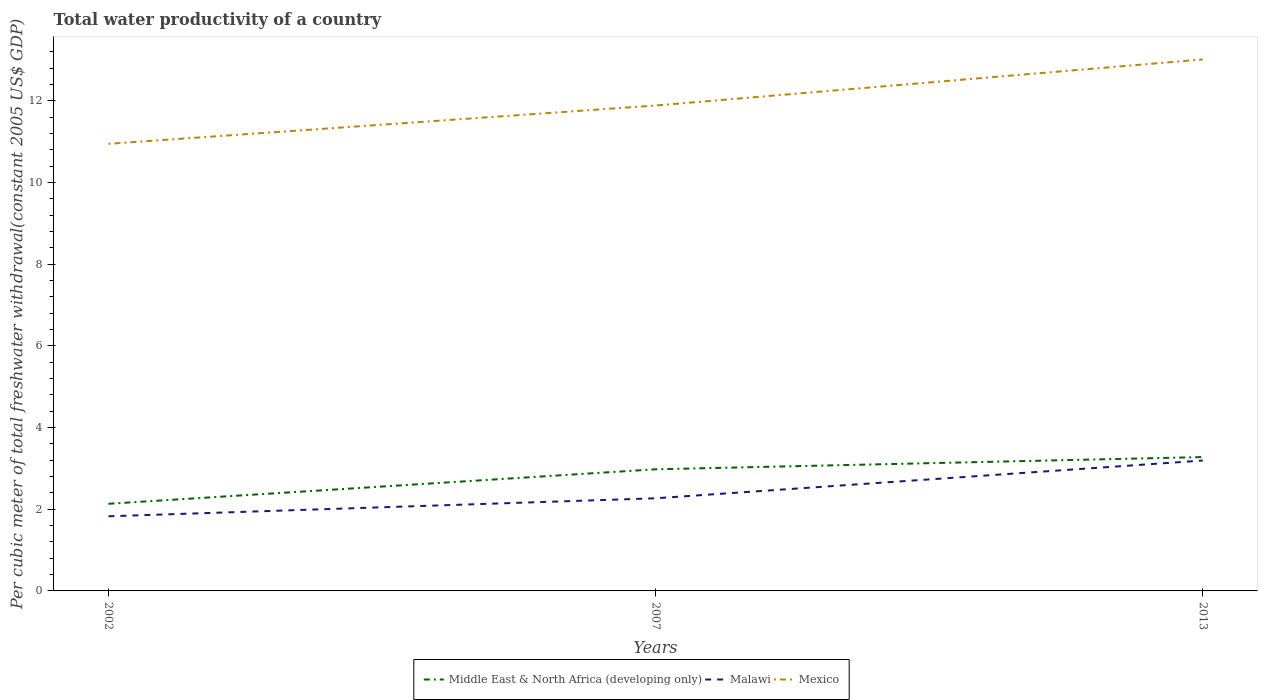Across all years, what is the maximum total water productivity in Mexico?
Keep it short and to the point. 10.95. In which year was the total water productivity in Malawi maximum?
Offer a terse response. 2002. What is the total total water productivity in Malawi in the graph?
Make the answer very short. -0.44. What is the difference between the highest and the second highest total water productivity in Middle East & North Africa (developing only)?
Provide a short and direct response. 1.14. What is the difference between the highest and the lowest total water productivity in Malawi?
Give a very brief answer. 1. Is the total water productivity in Mexico strictly greater than the total water productivity in Middle East & North Africa (developing only) over the years?
Provide a short and direct response. No. How many lines are there?
Keep it short and to the point. 3. Does the graph contain any zero values?
Offer a very short reply. No. Where does the legend appear in the graph?
Give a very brief answer. Bottom center. How many legend labels are there?
Keep it short and to the point. 3. How are the legend labels stacked?
Your answer should be compact. Horizontal. What is the title of the graph?
Keep it short and to the point. Total water productivity of a country. Does "Middle East & North Africa (all income levels)" appear as one of the legend labels in the graph?
Provide a short and direct response. No. What is the label or title of the X-axis?
Your answer should be compact. Years. What is the label or title of the Y-axis?
Give a very brief answer. Per cubic meter of total freshwater withdrawal(constant 2005 US$ GDP). What is the Per cubic meter of total freshwater withdrawal(constant 2005 US$ GDP) in Middle East & North Africa (developing only) in 2002?
Your answer should be compact. 2.13. What is the Per cubic meter of total freshwater withdrawal(constant 2005 US$ GDP) of Malawi in 2002?
Ensure brevity in your answer.  1.83. What is the Per cubic meter of total freshwater withdrawal(constant 2005 US$ GDP) in Mexico in 2002?
Your answer should be very brief. 10.95. What is the Per cubic meter of total freshwater withdrawal(constant 2005 US$ GDP) in Middle East & North Africa (developing only) in 2007?
Offer a terse response. 2.98. What is the Per cubic meter of total freshwater withdrawal(constant 2005 US$ GDP) in Malawi in 2007?
Give a very brief answer. 2.27. What is the Per cubic meter of total freshwater withdrawal(constant 2005 US$ GDP) in Mexico in 2007?
Your answer should be very brief. 11.89. What is the Per cubic meter of total freshwater withdrawal(constant 2005 US$ GDP) of Middle East & North Africa (developing only) in 2013?
Your response must be concise. 3.28. What is the Per cubic meter of total freshwater withdrawal(constant 2005 US$ GDP) in Malawi in 2013?
Ensure brevity in your answer.  3.19. What is the Per cubic meter of total freshwater withdrawal(constant 2005 US$ GDP) of Mexico in 2013?
Provide a short and direct response. 13.02. Across all years, what is the maximum Per cubic meter of total freshwater withdrawal(constant 2005 US$ GDP) of Middle East & North Africa (developing only)?
Offer a terse response. 3.28. Across all years, what is the maximum Per cubic meter of total freshwater withdrawal(constant 2005 US$ GDP) in Malawi?
Ensure brevity in your answer.  3.19. Across all years, what is the maximum Per cubic meter of total freshwater withdrawal(constant 2005 US$ GDP) in Mexico?
Keep it short and to the point. 13.02. Across all years, what is the minimum Per cubic meter of total freshwater withdrawal(constant 2005 US$ GDP) of Middle East & North Africa (developing only)?
Make the answer very short. 2.13. Across all years, what is the minimum Per cubic meter of total freshwater withdrawal(constant 2005 US$ GDP) in Malawi?
Make the answer very short. 1.83. Across all years, what is the minimum Per cubic meter of total freshwater withdrawal(constant 2005 US$ GDP) in Mexico?
Your answer should be compact. 10.95. What is the total Per cubic meter of total freshwater withdrawal(constant 2005 US$ GDP) in Middle East & North Africa (developing only) in the graph?
Your answer should be compact. 8.39. What is the total Per cubic meter of total freshwater withdrawal(constant 2005 US$ GDP) in Malawi in the graph?
Your answer should be compact. 7.29. What is the total Per cubic meter of total freshwater withdrawal(constant 2005 US$ GDP) in Mexico in the graph?
Ensure brevity in your answer.  35.85. What is the difference between the Per cubic meter of total freshwater withdrawal(constant 2005 US$ GDP) in Middle East & North Africa (developing only) in 2002 and that in 2007?
Give a very brief answer. -0.84. What is the difference between the Per cubic meter of total freshwater withdrawal(constant 2005 US$ GDP) of Malawi in 2002 and that in 2007?
Make the answer very short. -0.44. What is the difference between the Per cubic meter of total freshwater withdrawal(constant 2005 US$ GDP) of Mexico in 2002 and that in 2007?
Your answer should be compact. -0.94. What is the difference between the Per cubic meter of total freshwater withdrawal(constant 2005 US$ GDP) in Middle East & North Africa (developing only) in 2002 and that in 2013?
Make the answer very short. -1.14. What is the difference between the Per cubic meter of total freshwater withdrawal(constant 2005 US$ GDP) in Malawi in 2002 and that in 2013?
Keep it short and to the point. -1.37. What is the difference between the Per cubic meter of total freshwater withdrawal(constant 2005 US$ GDP) of Mexico in 2002 and that in 2013?
Your response must be concise. -2.07. What is the difference between the Per cubic meter of total freshwater withdrawal(constant 2005 US$ GDP) in Middle East & North Africa (developing only) in 2007 and that in 2013?
Offer a very short reply. -0.3. What is the difference between the Per cubic meter of total freshwater withdrawal(constant 2005 US$ GDP) in Malawi in 2007 and that in 2013?
Your answer should be very brief. -0.92. What is the difference between the Per cubic meter of total freshwater withdrawal(constant 2005 US$ GDP) of Mexico in 2007 and that in 2013?
Ensure brevity in your answer.  -1.13. What is the difference between the Per cubic meter of total freshwater withdrawal(constant 2005 US$ GDP) in Middle East & North Africa (developing only) in 2002 and the Per cubic meter of total freshwater withdrawal(constant 2005 US$ GDP) in Malawi in 2007?
Provide a succinct answer. -0.13. What is the difference between the Per cubic meter of total freshwater withdrawal(constant 2005 US$ GDP) of Middle East & North Africa (developing only) in 2002 and the Per cubic meter of total freshwater withdrawal(constant 2005 US$ GDP) of Mexico in 2007?
Your answer should be compact. -9.75. What is the difference between the Per cubic meter of total freshwater withdrawal(constant 2005 US$ GDP) in Malawi in 2002 and the Per cubic meter of total freshwater withdrawal(constant 2005 US$ GDP) in Mexico in 2007?
Provide a succinct answer. -10.06. What is the difference between the Per cubic meter of total freshwater withdrawal(constant 2005 US$ GDP) in Middle East & North Africa (developing only) in 2002 and the Per cubic meter of total freshwater withdrawal(constant 2005 US$ GDP) in Malawi in 2013?
Keep it short and to the point. -1.06. What is the difference between the Per cubic meter of total freshwater withdrawal(constant 2005 US$ GDP) of Middle East & North Africa (developing only) in 2002 and the Per cubic meter of total freshwater withdrawal(constant 2005 US$ GDP) of Mexico in 2013?
Make the answer very short. -10.88. What is the difference between the Per cubic meter of total freshwater withdrawal(constant 2005 US$ GDP) of Malawi in 2002 and the Per cubic meter of total freshwater withdrawal(constant 2005 US$ GDP) of Mexico in 2013?
Keep it short and to the point. -11.19. What is the difference between the Per cubic meter of total freshwater withdrawal(constant 2005 US$ GDP) of Middle East & North Africa (developing only) in 2007 and the Per cubic meter of total freshwater withdrawal(constant 2005 US$ GDP) of Malawi in 2013?
Offer a very short reply. -0.21. What is the difference between the Per cubic meter of total freshwater withdrawal(constant 2005 US$ GDP) in Middle East & North Africa (developing only) in 2007 and the Per cubic meter of total freshwater withdrawal(constant 2005 US$ GDP) in Mexico in 2013?
Give a very brief answer. -10.04. What is the difference between the Per cubic meter of total freshwater withdrawal(constant 2005 US$ GDP) in Malawi in 2007 and the Per cubic meter of total freshwater withdrawal(constant 2005 US$ GDP) in Mexico in 2013?
Your answer should be very brief. -10.75. What is the average Per cubic meter of total freshwater withdrawal(constant 2005 US$ GDP) of Middle East & North Africa (developing only) per year?
Your response must be concise. 2.8. What is the average Per cubic meter of total freshwater withdrawal(constant 2005 US$ GDP) in Malawi per year?
Offer a very short reply. 2.43. What is the average Per cubic meter of total freshwater withdrawal(constant 2005 US$ GDP) of Mexico per year?
Give a very brief answer. 11.95. In the year 2002, what is the difference between the Per cubic meter of total freshwater withdrawal(constant 2005 US$ GDP) in Middle East & North Africa (developing only) and Per cubic meter of total freshwater withdrawal(constant 2005 US$ GDP) in Malawi?
Make the answer very short. 0.31. In the year 2002, what is the difference between the Per cubic meter of total freshwater withdrawal(constant 2005 US$ GDP) of Middle East & North Africa (developing only) and Per cubic meter of total freshwater withdrawal(constant 2005 US$ GDP) of Mexico?
Keep it short and to the point. -8.82. In the year 2002, what is the difference between the Per cubic meter of total freshwater withdrawal(constant 2005 US$ GDP) of Malawi and Per cubic meter of total freshwater withdrawal(constant 2005 US$ GDP) of Mexico?
Your response must be concise. -9.12. In the year 2007, what is the difference between the Per cubic meter of total freshwater withdrawal(constant 2005 US$ GDP) in Middle East & North Africa (developing only) and Per cubic meter of total freshwater withdrawal(constant 2005 US$ GDP) in Malawi?
Ensure brevity in your answer.  0.71. In the year 2007, what is the difference between the Per cubic meter of total freshwater withdrawal(constant 2005 US$ GDP) of Middle East & North Africa (developing only) and Per cubic meter of total freshwater withdrawal(constant 2005 US$ GDP) of Mexico?
Offer a very short reply. -8.91. In the year 2007, what is the difference between the Per cubic meter of total freshwater withdrawal(constant 2005 US$ GDP) in Malawi and Per cubic meter of total freshwater withdrawal(constant 2005 US$ GDP) in Mexico?
Your answer should be very brief. -9.62. In the year 2013, what is the difference between the Per cubic meter of total freshwater withdrawal(constant 2005 US$ GDP) of Middle East & North Africa (developing only) and Per cubic meter of total freshwater withdrawal(constant 2005 US$ GDP) of Malawi?
Give a very brief answer. 0.08. In the year 2013, what is the difference between the Per cubic meter of total freshwater withdrawal(constant 2005 US$ GDP) of Middle East & North Africa (developing only) and Per cubic meter of total freshwater withdrawal(constant 2005 US$ GDP) of Mexico?
Your answer should be compact. -9.74. In the year 2013, what is the difference between the Per cubic meter of total freshwater withdrawal(constant 2005 US$ GDP) in Malawi and Per cubic meter of total freshwater withdrawal(constant 2005 US$ GDP) in Mexico?
Your answer should be very brief. -9.82. What is the ratio of the Per cubic meter of total freshwater withdrawal(constant 2005 US$ GDP) of Middle East & North Africa (developing only) in 2002 to that in 2007?
Provide a short and direct response. 0.72. What is the ratio of the Per cubic meter of total freshwater withdrawal(constant 2005 US$ GDP) in Malawi in 2002 to that in 2007?
Give a very brief answer. 0.81. What is the ratio of the Per cubic meter of total freshwater withdrawal(constant 2005 US$ GDP) in Mexico in 2002 to that in 2007?
Your answer should be very brief. 0.92. What is the ratio of the Per cubic meter of total freshwater withdrawal(constant 2005 US$ GDP) of Middle East & North Africa (developing only) in 2002 to that in 2013?
Give a very brief answer. 0.65. What is the ratio of the Per cubic meter of total freshwater withdrawal(constant 2005 US$ GDP) in Malawi in 2002 to that in 2013?
Give a very brief answer. 0.57. What is the ratio of the Per cubic meter of total freshwater withdrawal(constant 2005 US$ GDP) of Mexico in 2002 to that in 2013?
Your answer should be compact. 0.84. What is the ratio of the Per cubic meter of total freshwater withdrawal(constant 2005 US$ GDP) in Middle East & North Africa (developing only) in 2007 to that in 2013?
Your response must be concise. 0.91. What is the ratio of the Per cubic meter of total freshwater withdrawal(constant 2005 US$ GDP) of Malawi in 2007 to that in 2013?
Your answer should be very brief. 0.71. What is the ratio of the Per cubic meter of total freshwater withdrawal(constant 2005 US$ GDP) of Mexico in 2007 to that in 2013?
Your response must be concise. 0.91. What is the difference between the highest and the second highest Per cubic meter of total freshwater withdrawal(constant 2005 US$ GDP) in Middle East & North Africa (developing only)?
Your response must be concise. 0.3. What is the difference between the highest and the second highest Per cubic meter of total freshwater withdrawal(constant 2005 US$ GDP) in Malawi?
Make the answer very short. 0.92. What is the difference between the highest and the second highest Per cubic meter of total freshwater withdrawal(constant 2005 US$ GDP) in Mexico?
Keep it short and to the point. 1.13. What is the difference between the highest and the lowest Per cubic meter of total freshwater withdrawal(constant 2005 US$ GDP) in Middle East & North Africa (developing only)?
Offer a terse response. 1.14. What is the difference between the highest and the lowest Per cubic meter of total freshwater withdrawal(constant 2005 US$ GDP) in Malawi?
Keep it short and to the point. 1.37. What is the difference between the highest and the lowest Per cubic meter of total freshwater withdrawal(constant 2005 US$ GDP) of Mexico?
Your answer should be very brief. 2.07. 